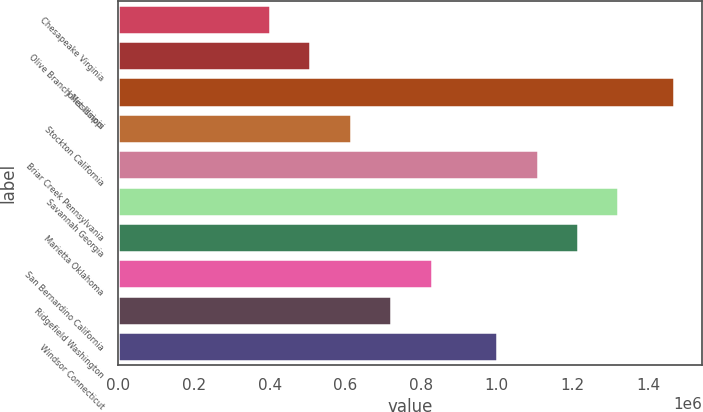Convert chart. <chart><loc_0><loc_0><loc_500><loc_500><bar_chart><fcel>Chesapeake Virginia<fcel>Olive Branch Mississippi<fcel>Joliet Illinois<fcel>Stockton California<fcel>Briar Creek Pennsylvania<fcel>Savannah Georgia<fcel>Marietta Oklahoma<fcel>San Bernardino California<fcel>Ridgefield Washington<fcel>Windsor Connecticut<nl><fcel>400000<fcel>507000<fcel>1.47e+06<fcel>614000<fcel>1.108e+06<fcel>1.322e+06<fcel>1.215e+06<fcel>828000<fcel>721000<fcel>1.001e+06<nl></chart> 